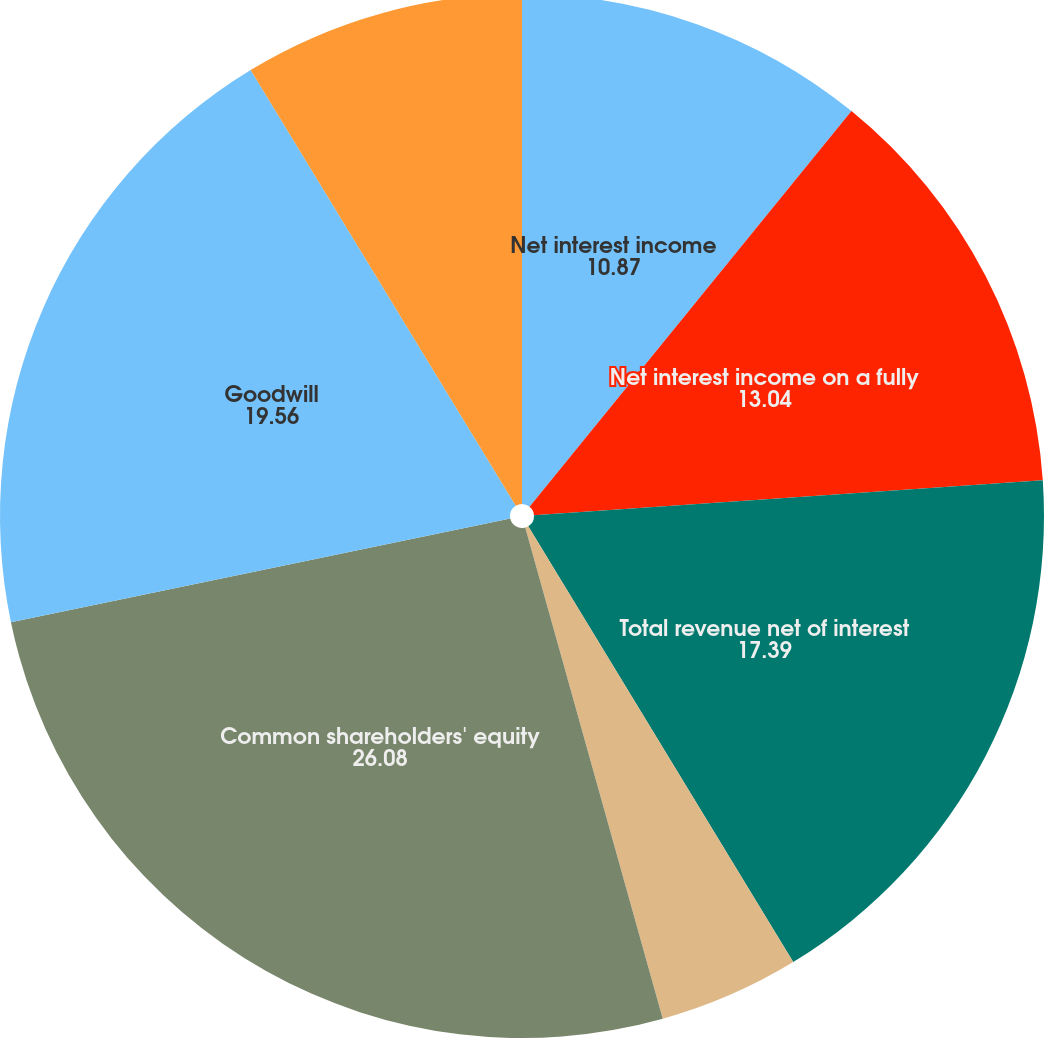Convert chart to OTSL. <chart><loc_0><loc_0><loc_500><loc_500><pie_chart><fcel>Net interest income<fcel>Fully taxable-equivalent<fcel>Net interest income on a fully<fcel>Total revenue net of interest<fcel>Income tax expense (benefit)<fcel>Common shareholders' equity<fcel>Goodwill<fcel>Intangible assets (excluding<nl><fcel>10.87%<fcel>0.0%<fcel>13.04%<fcel>17.39%<fcel>4.35%<fcel>26.08%<fcel>19.56%<fcel>8.7%<nl></chart> 